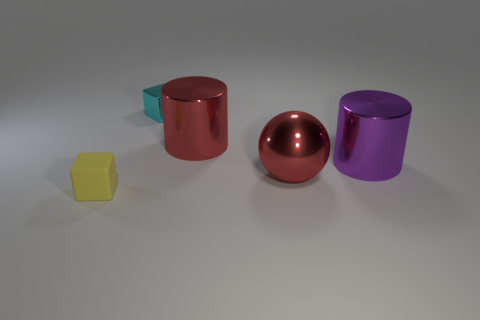Is the color of the large shiny object that is in front of the big purple thing the same as the large cylinder that is left of the large sphere?
Your response must be concise. Yes. How many other objects are there of the same color as the large metal sphere?
Your response must be concise. 1. How many objects are large objects that are on the right side of the big red ball or small cyan metal objects?
Your answer should be very brief. 2. There is a small thing that is made of the same material as the large purple object; what shape is it?
Offer a terse response. Cube. The object that is both right of the small metallic block and in front of the purple cylinder is what color?
Your answer should be compact. Red. What number of cylinders are tiny yellow objects or cyan metallic things?
Your response must be concise. 0. What number of shiny balls are the same size as the yellow matte cube?
Ensure brevity in your answer.  0. There is a tiny cube that is behind the large purple metallic object; how many tiny blocks are left of it?
Your answer should be very brief. 1. There is a thing that is in front of the big purple thing and behind the small yellow rubber thing; what is its size?
Your answer should be compact. Large. Are there more big red metallic things than objects?
Keep it short and to the point. No. 